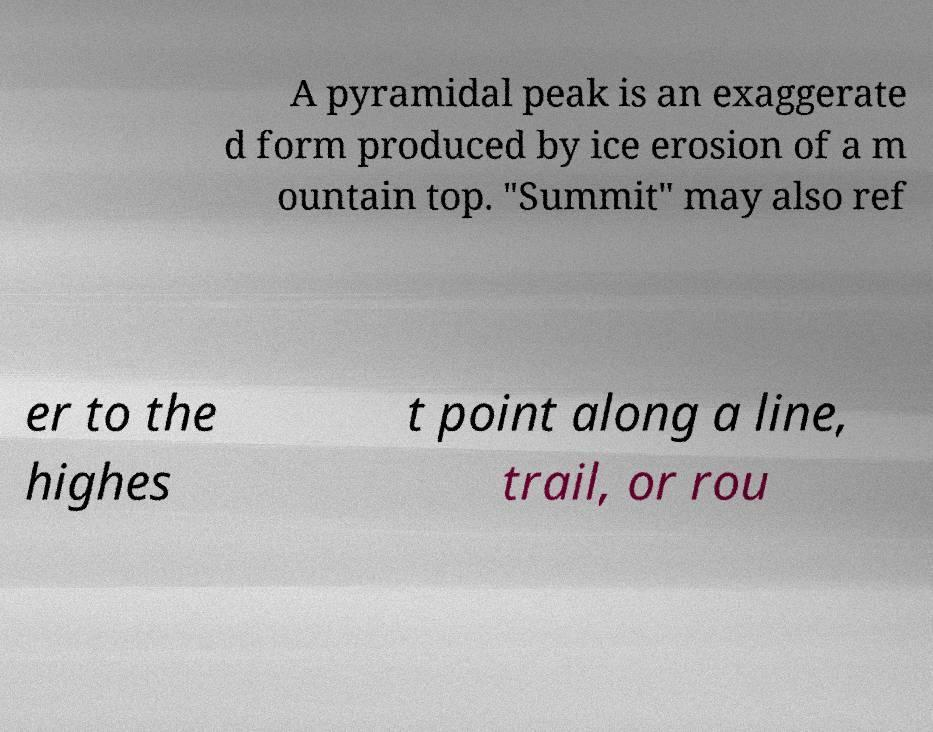I need the written content from this picture converted into text. Can you do that? A pyramidal peak is an exaggerate d form produced by ice erosion of a m ountain top. "Summit" may also ref er to the highes t point along a line, trail, or rou 